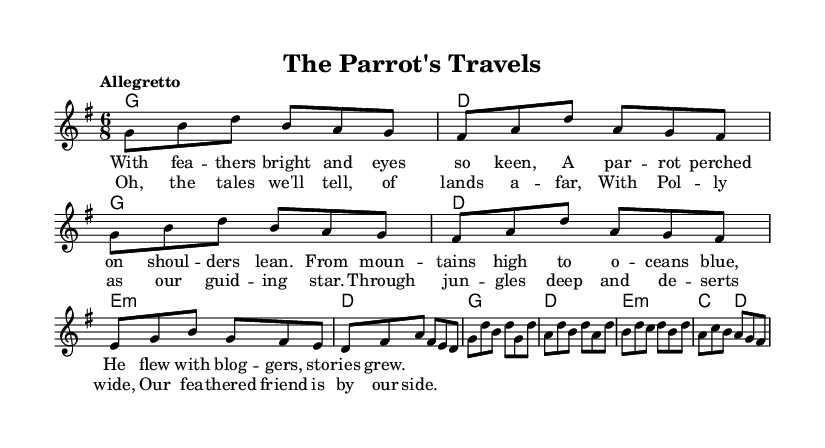What is the key signature of this music? The key signature is indicated at the beginning of the staff and shows one sharp, which is characteristic of G major.
Answer: G major What is the time signature of this music? The time signature is noted right after the key signature, showing that each measure contains six eighth notes, represented as 6/8.
Answer: 6/8 What is the tempo marking for this piece? The tempo marking is located near the beginning of the score and states “Allegretto,” which suggests a moderately fast pace.
Answer: Allegretto How many measures are in the melody section? The melody consists of multiple phrases, and counting the individual measures from start to finish shows there are 12 measures total.
Answer: 12 What is the first note of the chorus? The first note of the chorus as indicated in the melody corresponds to the beginning of the chorus lyrics, starting with "Oh," which is represented by the note G.
Answer: G What is the form of this music piece? The form is derived from the structure of the sections labeled as verse and chorus, which alternate in a typical folk storytelling style common in this genre.
Answer: Verse-Chorus How does the accompaniment change between the verse and chorus? By observing the harmonies, the chord progression shifts subtly between the verse, which employs G and D chords, to the chorus that features a different sequence, indicating a change in texture and support for the melody.
Answer: G and D to G and E minor 